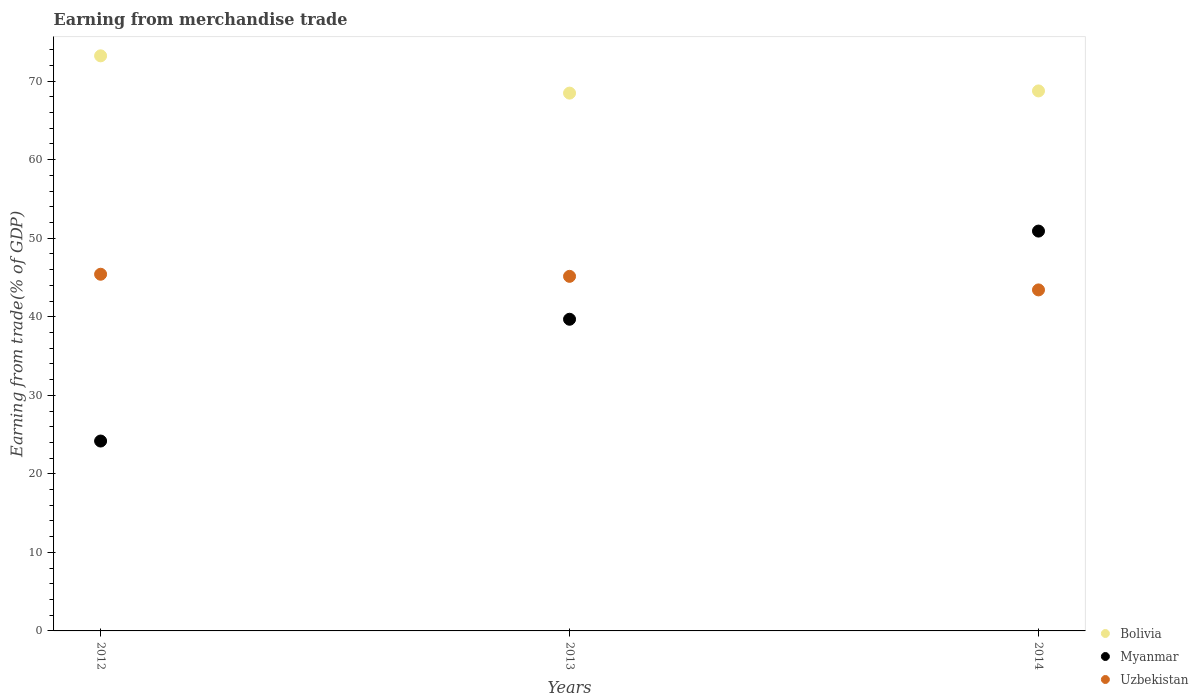Is the number of dotlines equal to the number of legend labels?
Your response must be concise. Yes. What is the earnings from trade in Bolivia in 2012?
Your response must be concise. 73.22. Across all years, what is the maximum earnings from trade in Bolivia?
Provide a short and direct response. 73.22. Across all years, what is the minimum earnings from trade in Uzbekistan?
Make the answer very short. 43.42. In which year was the earnings from trade in Myanmar minimum?
Offer a terse response. 2012. What is the total earnings from trade in Uzbekistan in the graph?
Provide a short and direct response. 133.98. What is the difference between the earnings from trade in Myanmar in 2013 and that in 2014?
Make the answer very short. -11.23. What is the difference between the earnings from trade in Uzbekistan in 2013 and the earnings from trade in Bolivia in 2014?
Provide a short and direct response. -23.61. What is the average earnings from trade in Myanmar per year?
Ensure brevity in your answer.  38.26. In the year 2012, what is the difference between the earnings from trade in Bolivia and earnings from trade in Uzbekistan?
Make the answer very short. 27.81. In how many years, is the earnings from trade in Myanmar greater than 36 %?
Keep it short and to the point. 2. What is the ratio of the earnings from trade in Myanmar in 2013 to that in 2014?
Offer a very short reply. 0.78. What is the difference between the highest and the second highest earnings from trade in Myanmar?
Your response must be concise. 11.23. What is the difference between the highest and the lowest earnings from trade in Uzbekistan?
Offer a terse response. 1.99. In how many years, is the earnings from trade in Myanmar greater than the average earnings from trade in Myanmar taken over all years?
Keep it short and to the point. 2. Is the earnings from trade in Bolivia strictly greater than the earnings from trade in Uzbekistan over the years?
Your response must be concise. Yes. Is the earnings from trade in Uzbekistan strictly less than the earnings from trade in Myanmar over the years?
Make the answer very short. No. How many dotlines are there?
Give a very brief answer. 3. Are the values on the major ticks of Y-axis written in scientific E-notation?
Your answer should be very brief. No. Does the graph contain any zero values?
Keep it short and to the point. No. Does the graph contain grids?
Your response must be concise. No. How are the legend labels stacked?
Ensure brevity in your answer.  Vertical. What is the title of the graph?
Provide a succinct answer. Earning from merchandise trade. What is the label or title of the X-axis?
Offer a very short reply. Years. What is the label or title of the Y-axis?
Your response must be concise. Earning from trade(% of GDP). What is the Earning from trade(% of GDP) in Bolivia in 2012?
Ensure brevity in your answer.  73.22. What is the Earning from trade(% of GDP) in Myanmar in 2012?
Your answer should be very brief. 24.18. What is the Earning from trade(% of GDP) of Uzbekistan in 2012?
Provide a short and direct response. 45.41. What is the Earning from trade(% of GDP) of Bolivia in 2013?
Your answer should be compact. 68.48. What is the Earning from trade(% of GDP) in Myanmar in 2013?
Offer a very short reply. 39.68. What is the Earning from trade(% of GDP) in Uzbekistan in 2013?
Keep it short and to the point. 45.15. What is the Earning from trade(% of GDP) of Bolivia in 2014?
Your response must be concise. 68.76. What is the Earning from trade(% of GDP) in Myanmar in 2014?
Provide a short and direct response. 50.91. What is the Earning from trade(% of GDP) in Uzbekistan in 2014?
Give a very brief answer. 43.42. Across all years, what is the maximum Earning from trade(% of GDP) in Bolivia?
Ensure brevity in your answer.  73.22. Across all years, what is the maximum Earning from trade(% of GDP) of Myanmar?
Your answer should be compact. 50.91. Across all years, what is the maximum Earning from trade(% of GDP) of Uzbekistan?
Provide a short and direct response. 45.41. Across all years, what is the minimum Earning from trade(% of GDP) of Bolivia?
Provide a short and direct response. 68.48. Across all years, what is the minimum Earning from trade(% of GDP) of Myanmar?
Keep it short and to the point. 24.18. Across all years, what is the minimum Earning from trade(% of GDP) in Uzbekistan?
Give a very brief answer. 43.42. What is the total Earning from trade(% of GDP) of Bolivia in the graph?
Offer a very short reply. 210.46. What is the total Earning from trade(% of GDP) in Myanmar in the graph?
Your answer should be very brief. 114.77. What is the total Earning from trade(% of GDP) of Uzbekistan in the graph?
Offer a very short reply. 133.98. What is the difference between the Earning from trade(% of GDP) of Bolivia in 2012 and that in 2013?
Your answer should be very brief. 4.75. What is the difference between the Earning from trade(% of GDP) of Myanmar in 2012 and that in 2013?
Your answer should be compact. -15.51. What is the difference between the Earning from trade(% of GDP) in Uzbekistan in 2012 and that in 2013?
Ensure brevity in your answer.  0.27. What is the difference between the Earning from trade(% of GDP) of Bolivia in 2012 and that in 2014?
Make the answer very short. 4.47. What is the difference between the Earning from trade(% of GDP) in Myanmar in 2012 and that in 2014?
Make the answer very short. -26.73. What is the difference between the Earning from trade(% of GDP) of Uzbekistan in 2012 and that in 2014?
Provide a succinct answer. 1.99. What is the difference between the Earning from trade(% of GDP) in Bolivia in 2013 and that in 2014?
Your answer should be compact. -0.28. What is the difference between the Earning from trade(% of GDP) of Myanmar in 2013 and that in 2014?
Your answer should be compact. -11.23. What is the difference between the Earning from trade(% of GDP) of Uzbekistan in 2013 and that in 2014?
Your answer should be very brief. 1.73. What is the difference between the Earning from trade(% of GDP) of Bolivia in 2012 and the Earning from trade(% of GDP) of Myanmar in 2013?
Keep it short and to the point. 33.54. What is the difference between the Earning from trade(% of GDP) in Bolivia in 2012 and the Earning from trade(% of GDP) in Uzbekistan in 2013?
Provide a short and direct response. 28.08. What is the difference between the Earning from trade(% of GDP) of Myanmar in 2012 and the Earning from trade(% of GDP) of Uzbekistan in 2013?
Make the answer very short. -20.97. What is the difference between the Earning from trade(% of GDP) of Bolivia in 2012 and the Earning from trade(% of GDP) of Myanmar in 2014?
Offer a terse response. 22.31. What is the difference between the Earning from trade(% of GDP) of Bolivia in 2012 and the Earning from trade(% of GDP) of Uzbekistan in 2014?
Your response must be concise. 29.8. What is the difference between the Earning from trade(% of GDP) in Myanmar in 2012 and the Earning from trade(% of GDP) in Uzbekistan in 2014?
Ensure brevity in your answer.  -19.24. What is the difference between the Earning from trade(% of GDP) of Bolivia in 2013 and the Earning from trade(% of GDP) of Myanmar in 2014?
Make the answer very short. 17.57. What is the difference between the Earning from trade(% of GDP) of Bolivia in 2013 and the Earning from trade(% of GDP) of Uzbekistan in 2014?
Offer a very short reply. 25.06. What is the difference between the Earning from trade(% of GDP) of Myanmar in 2013 and the Earning from trade(% of GDP) of Uzbekistan in 2014?
Your answer should be compact. -3.74. What is the average Earning from trade(% of GDP) in Bolivia per year?
Offer a very short reply. 70.15. What is the average Earning from trade(% of GDP) in Myanmar per year?
Make the answer very short. 38.26. What is the average Earning from trade(% of GDP) in Uzbekistan per year?
Your answer should be very brief. 44.66. In the year 2012, what is the difference between the Earning from trade(% of GDP) in Bolivia and Earning from trade(% of GDP) in Myanmar?
Give a very brief answer. 49.05. In the year 2012, what is the difference between the Earning from trade(% of GDP) of Bolivia and Earning from trade(% of GDP) of Uzbekistan?
Ensure brevity in your answer.  27.81. In the year 2012, what is the difference between the Earning from trade(% of GDP) of Myanmar and Earning from trade(% of GDP) of Uzbekistan?
Offer a terse response. -21.24. In the year 2013, what is the difference between the Earning from trade(% of GDP) of Bolivia and Earning from trade(% of GDP) of Myanmar?
Provide a short and direct response. 28.79. In the year 2013, what is the difference between the Earning from trade(% of GDP) of Bolivia and Earning from trade(% of GDP) of Uzbekistan?
Your answer should be compact. 23.33. In the year 2013, what is the difference between the Earning from trade(% of GDP) of Myanmar and Earning from trade(% of GDP) of Uzbekistan?
Ensure brevity in your answer.  -5.46. In the year 2014, what is the difference between the Earning from trade(% of GDP) in Bolivia and Earning from trade(% of GDP) in Myanmar?
Provide a short and direct response. 17.85. In the year 2014, what is the difference between the Earning from trade(% of GDP) in Bolivia and Earning from trade(% of GDP) in Uzbekistan?
Ensure brevity in your answer.  25.34. In the year 2014, what is the difference between the Earning from trade(% of GDP) of Myanmar and Earning from trade(% of GDP) of Uzbekistan?
Keep it short and to the point. 7.49. What is the ratio of the Earning from trade(% of GDP) in Bolivia in 2012 to that in 2013?
Give a very brief answer. 1.07. What is the ratio of the Earning from trade(% of GDP) in Myanmar in 2012 to that in 2013?
Ensure brevity in your answer.  0.61. What is the ratio of the Earning from trade(% of GDP) of Uzbekistan in 2012 to that in 2013?
Your answer should be compact. 1.01. What is the ratio of the Earning from trade(% of GDP) of Bolivia in 2012 to that in 2014?
Make the answer very short. 1.06. What is the ratio of the Earning from trade(% of GDP) of Myanmar in 2012 to that in 2014?
Make the answer very short. 0.47. What is the ratio of the Earning from trade(% of GDP) of Uzbekistan in 2012 to that in 2014?
Give a very brief answer. 1.05. What is the ratio of the Earning from trade(% of GDP) in Bolivia in 2013 to that in 2014?
Keep it short and to the point. 1. What is the ratio of the Earning from trade(% of GDP) of Myanmar in 2013 to that in 2014?
Make the answer very short. 0.78. What is the ratio of the Earning from trade(% of GDP) in Uzbekistan in 2013 to that in 2014?
Give a very brief answer. 1.04. What is the difference between the highest and the second highest Earning from trade(% of GDP) of Bolivia?
Your response must be concise. 4.47. What is the difference between the highest and the second highest Earning from trade(% of GDP) in Myanmar?
Offer a terse response. 11.23. What is the difference between the highest and the second highest Earning from trade(% of GDP) of Uzbekistan?
Your answer should be compact. 0.27. What is the difference between the highest and the lowest Earning from trade(% of GDP) in Bolivia?
Offer a terse response. 4.75. What is the difference between the highest and the lowest Earning from trade(% of GDP) in Myanmar?
Keep it short and to the point. 26.73. What is the difference between the highest and the lowest Earning from trade(% of GDP) in Uzbekistan?
Offer a terse response. 1.99. 